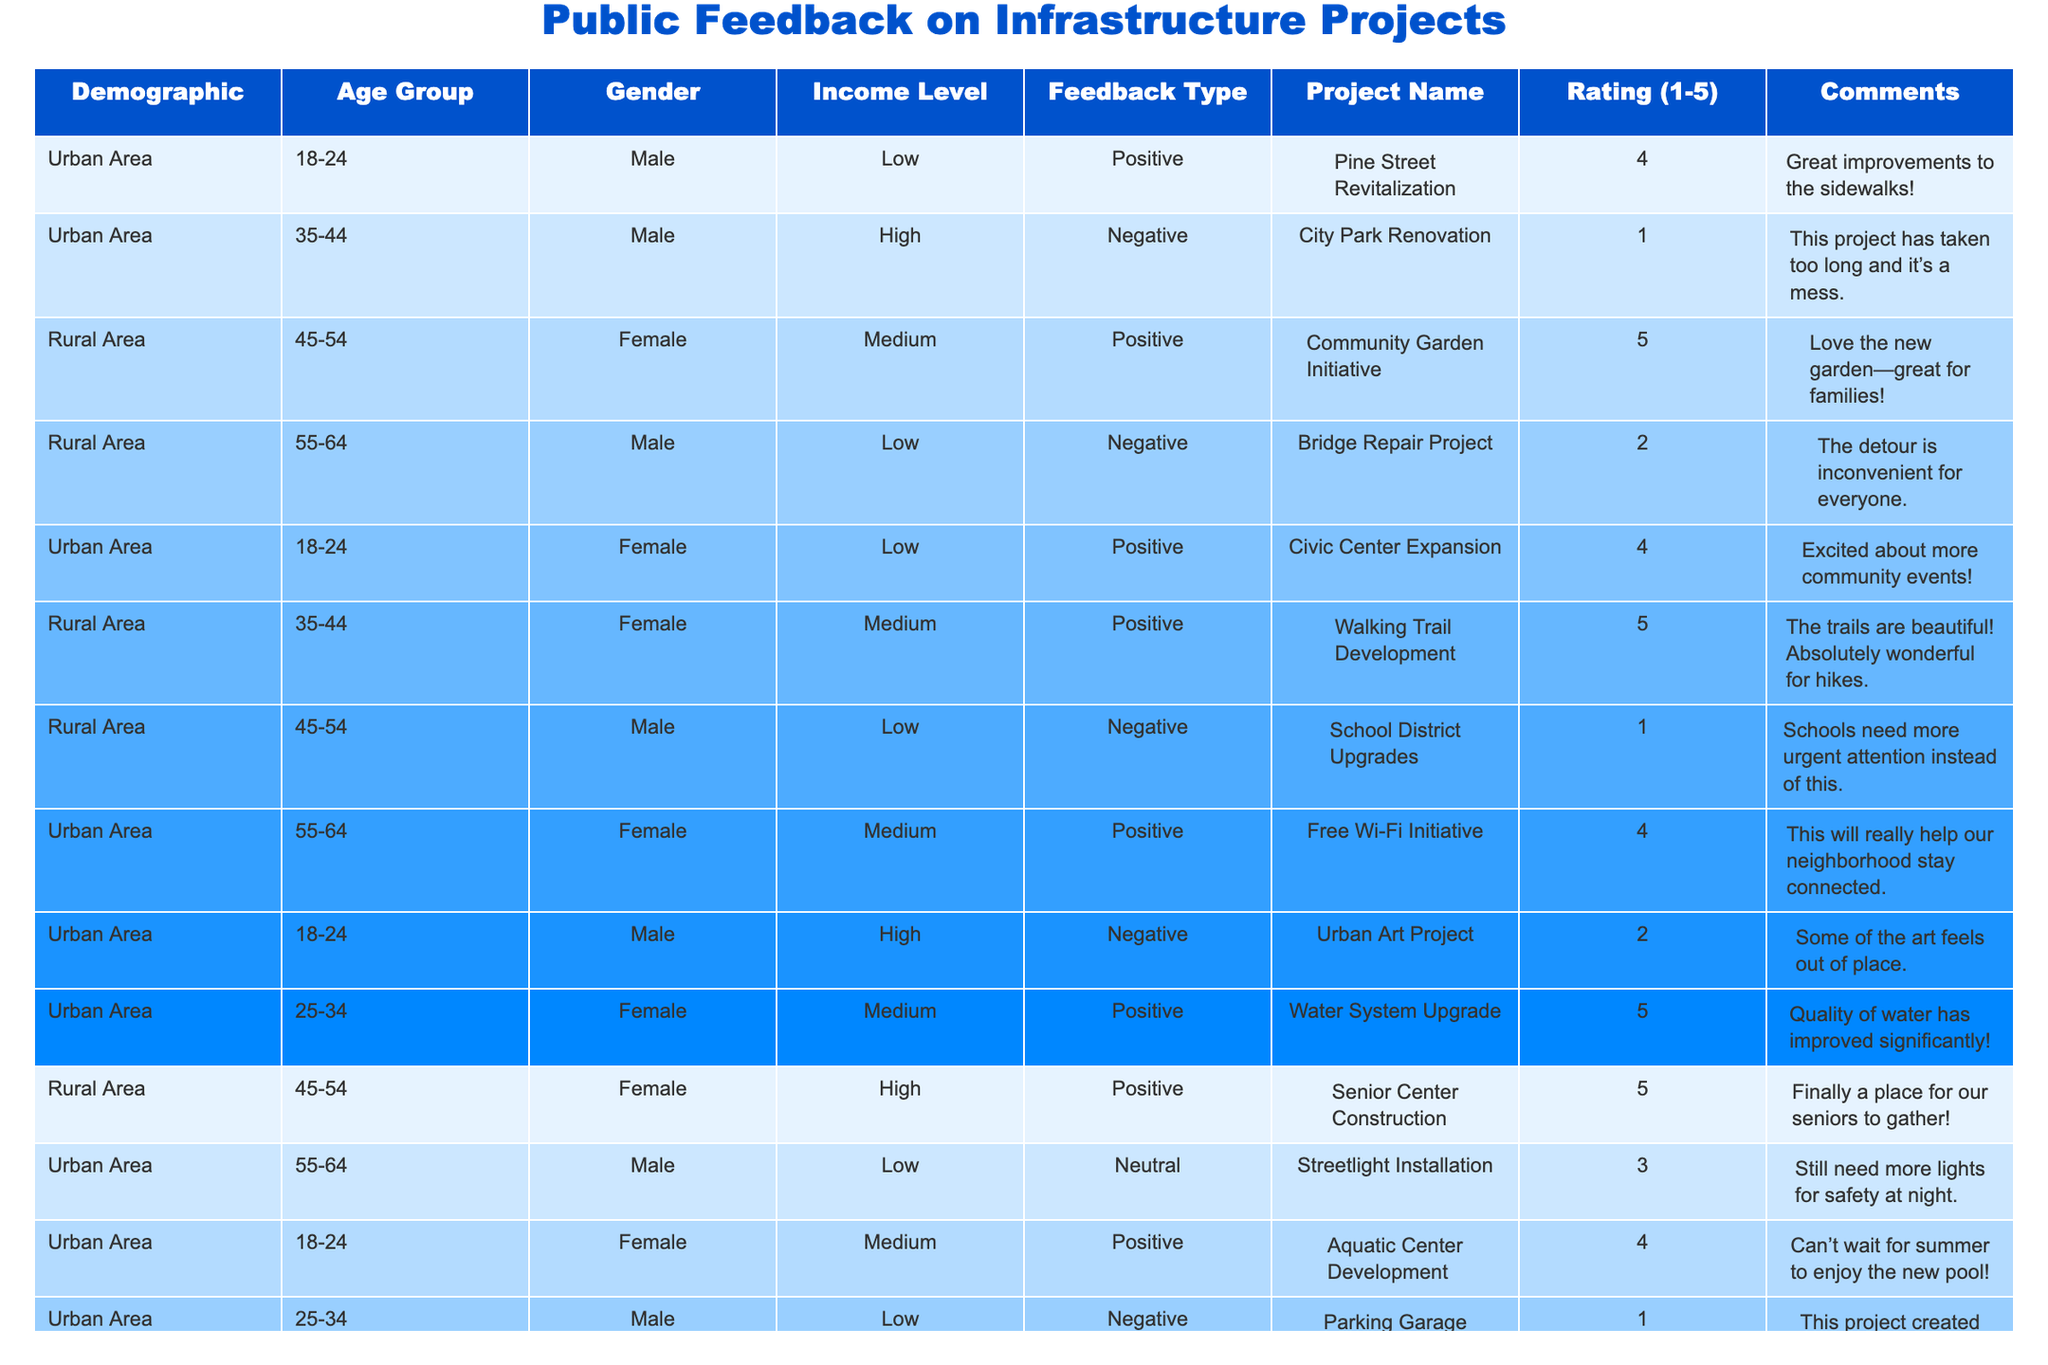What is the highest rating for any project? By scanning the "Rating (1-5)" column, the highest rating listed is 5, which appears for the "Community Garden Initiative," "Walking Trail Development," "Water System Upgrade," and "Senior Center Construction."
Answer: 5 How many projects received a negative rating? In the "Rating (1-5)" column, there are 5 entries with a rating of 1 or 2: "City Park Renovation," "Bridge Repair Project," "School District Upgrades," "Urban Art Project," and "Sustainable Housing Project." We count these to find there are 5 negative ratings.
Answer: 5 Which age group provided the most positive feedback? The "Age Group" column shows that the age group 35-44 has the highest number of positive feedback entries, specifically with the "Walking Trail Development," "Local Farmers Market," and "Wildlife Conservation Efforts," totaling 3 positive feedback entries.
Answer: 35-44 What is the average rating for projects in Urban Areas? The ratings for Urban Area projects are 4, 1, 4, 2, 1, 4, 3, and 4, totalling 2 + 1 + 4 + 1 + 2 + 4 + 3 + 4 = 21. There are 8 projects, so the average rating is 21/8 = 2.625.
Answer: 2.625 Is there a project with a neutral feedback rating? The rating of 3 is considered neutral. Checking the table, we find "Streetlight Installation" and "Litter Reduction Campaign" both have a neutral rating. Therefore, the answer is yes.
Answer: Yes Which demographic group gave the most positive feedback? Looking at the demographics with positive feedback, older female respondents (45-54 age group) gave positive feedback for two projects: "Community Garden Initiative" and "Senior Center Construction," totaling 2 entries. Counting all positive feedback entries by demographics shows this group is the highest.
Answer: Older females (45-54) What percentage of low-income respondents gave negative feedback? There are 5 low-income respondents in total, with 2 providing negative feedback ("City Park Renovation" and "School District Upgrades"). So, the percentage of low-income respondents who gave negative feedback is (2/5) * 100 = 40%.
Answer: 40% Were there more female or male respondents giving neutral feedback? From the table, we see the neutral feedback ratings associated with gender: males ("Streetlight Installation") and females ("Litter Reduction Campaign"). Both groups have 1 neutral feedback, so they are equal.
Answer: Equal (1 each) How many projects did not receive any feedback? By inspecting the table, all listed projects received feedback, as there are no additional projects without ratings given. Therefore, the count of projects with no feedback is zero.
Answer: 0 What is the overall sentiment of feedback for the "Urban Art Project"? The feedback rating for the "Urban Art Project" is recorded as 2, accompanied by a negative comment indicating some dissatisfaction. Therefore, the overall sentiment is negative.
Answer: Negative 